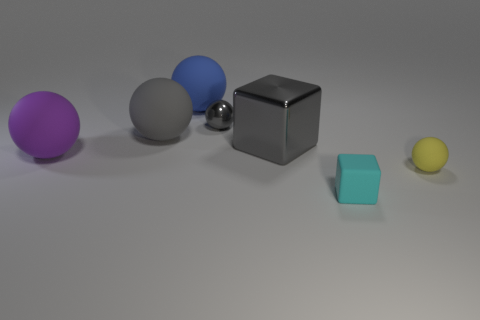What is the size of the yellow ball that is the same material as the small cyan object?
Your answer should be compact. Small. There is a block that is the same size as the blue matte sphere; what is it made of?
Provide a succinct answer. Metal. What is the material of the ball that is both in front of the large gray block and left of the blue ball?
Your answer should be very brief. Rubber. Is there a small metallic thing?
Give a very brief answer. Yes. There is a big cube; is it the same color as the metallic thing behind the big shiny block?
Ensure brevity in your answer.  Yes. There is a ball that is the same color as the small metallic thing; what material is it?
Your answer should be very brief. Rubber. What is the shape of the small object on the right side of the thing in front of the rubber sphere that is to the right of the blue matte thing?
Provide a short and direct response. Sphere. What is the shape of the small cyan rubber thing?
Provide a short and direct response. Cube. What color is the small object that is to the right of the matte block?
Provide a succinct answer. Yellow. Is the size of the cube in front of the yellow ball the same as the gray shiny ball?
Offer a terse response. Yes. 